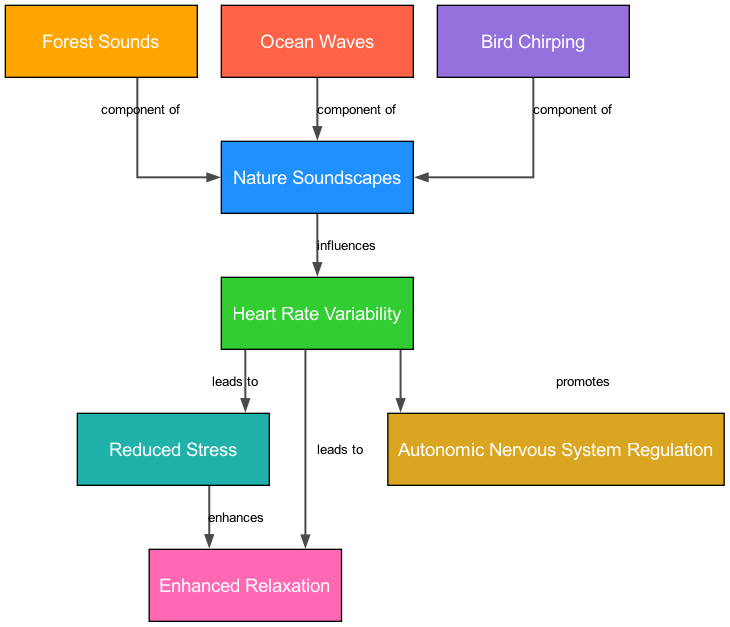What is the main influence on heart rate variability? The diagram indicates that "Nature Soundscapes" influences "Heart Rate Variability." This relationship is directly represented by the connecting edge in the diagram.
Answer: Nature Soundscapes How many components are listed under nature soundscapes? The diagram displays three components related to "Nature Soundscapes": Forest Sounds, Ocean Waves, and Bird Chirping. Counting these gives the total number of components.
Answer: Three Which component is associated with reduced stress? The flow from "Heart Rate Variability" to "Reduced Stress" indicates that better heart rate variability leads to reduced stress, making "Heart Rate Variability" the linkage.
Answer: Heart Rate Variability What does enhanced relaxation enhance? The arrow from "Reduced Stress" to "Enhanced Relaxation" suggests that reduced stress leads to enhanced relaxation, meaning the relationship enhances relaxation.
Answer: Enhanced Relaxation What promotes autonomic nervous system regulation? According to the diagram, "Heart Rate Variability" promotes "Autonomic Nervous System Regulation," as depicted by the directional edge connecting the two nodes.
Answer: Heart Rate Variability How does forest sounds relate to nature soundscapes? The diagram shows that "Forest Sounds" is a component of "Nature Soundscapes," demonstrated by the labeled edge connecting these two nodes.
Answer: Component of What outcome is linked to better heart rate variability? The outcomes linked to better heart rate variability include "Reduced Stress," "Enhanced Relaxation," and "ANS Regulation," which are all indicated in the diagram's flow.
Answer: Reduced Stress, Enhanced Relaxation, ANS Regulation Which node has the relationship of "enhances"? The edge indicating "enhances" connects "Reduced Stress" to "Enhanced Relaxation," identifying "Reduced Stress" as the starting node in this relationship.
Answer: Reduced Stress What are the three components of nature soundscapes? The three listed components of "Nature Soundscapes" in the diagram are "Forest Sounds," "Ocean Waves," and "Bird Chirping," which are clearly marked as components connected to the main node.
Answer: Forest Sounds, Ocean Waves, Bird Chirping 